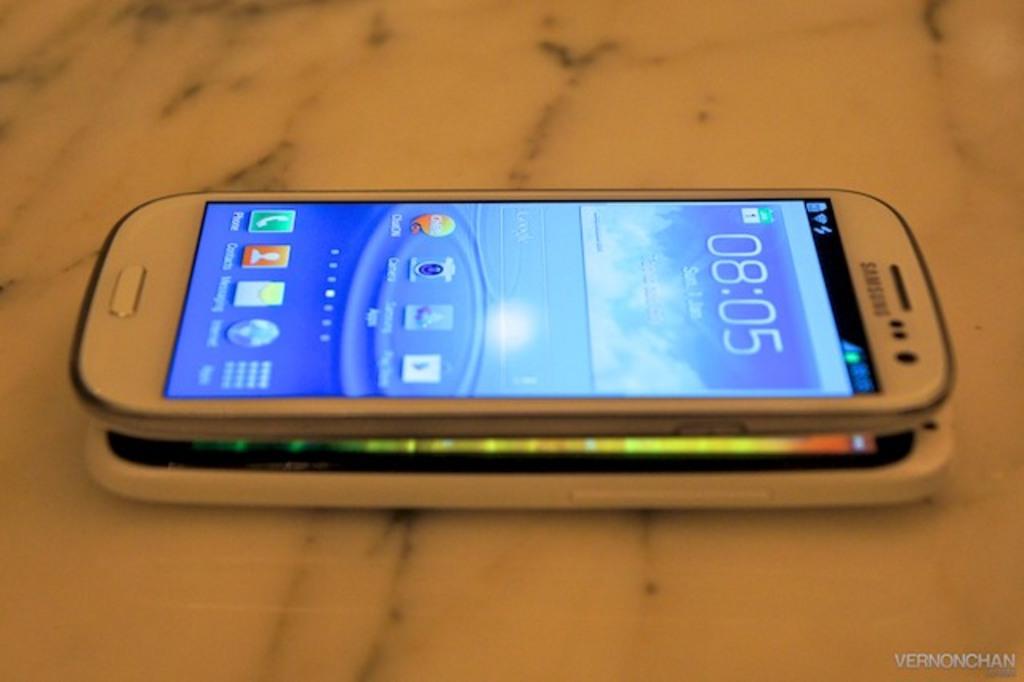What is the time shown?
Provide a succinct answer. 08:05. What brand phone?
Offer a very short reply. Samsung. 